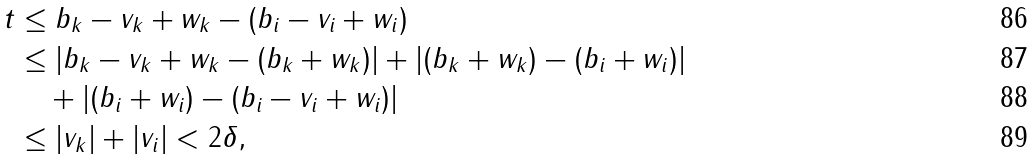<formula> <loc_0><loc_0><loc_500><loc_500>t & \leq b _ { k } - v _ { k } + w _ { k } - ( b _ { i } - v _ { i } + w _ { i } ) \\ & \leq | b _ { k } - v _ { k } + w _ { k } - ( b _ { k } + w _ { k } ) | + | ( b _ { k } + w _ { k } ) - ( b _ { i } + w _ { i } ) | \\ & \quad + | ( b _ { i } + w _ { i } ) - ( b _ { i } - v _ { i } + w _ { i } ) | \\ & \leq | v _ { k } | + | v _ { i } | < 2 \delta ,</formula> 